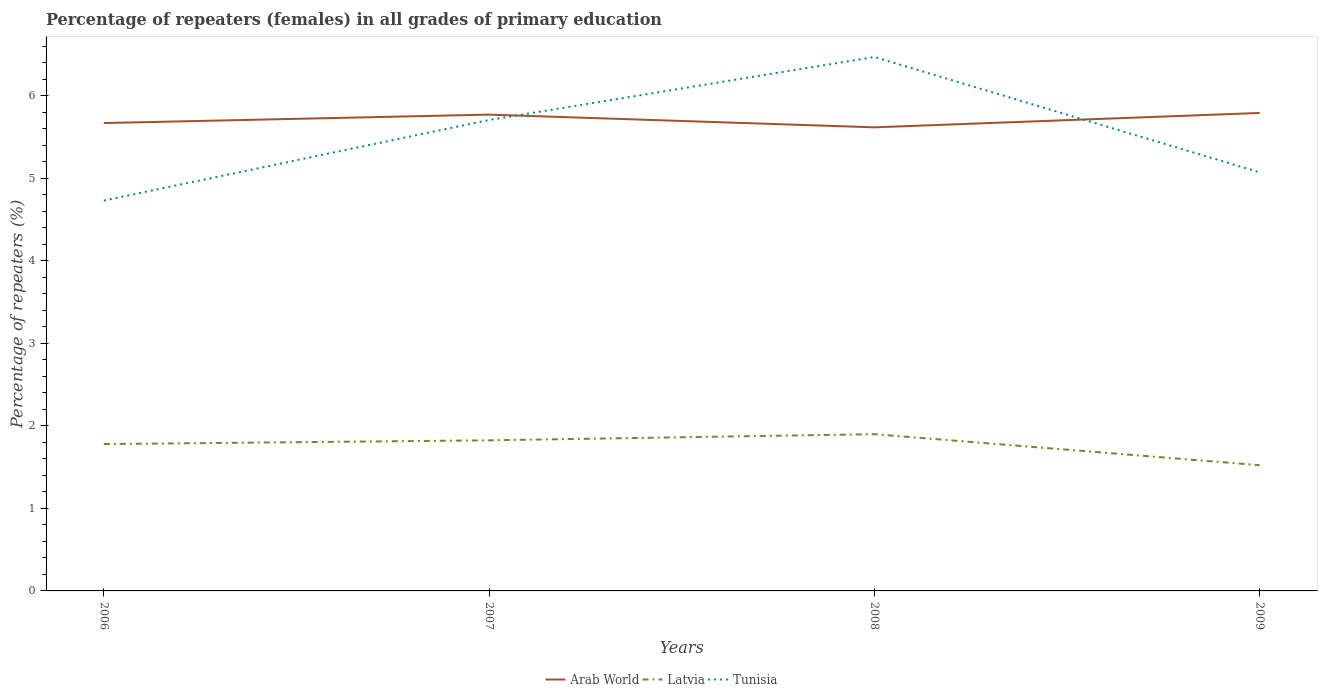How many different coloured lines are there?
Offer a very short reply. 3. Does the line corresponding to Tunisia intersect with the line corresponding to Arab World?
Offer a very short reply. Yes. Is the number of lines equal to the number of legend labels?
Provide a succinct answer. Yes. Across all years, what is the maximum percentage of repeaters (females) in Latvia?
Your answer should be compact. 1.52. What is the total percentage of repeaters (females) in Tunisia in the graph?
Provide a short and direct response. 1.4. What is the difference between the highest and the second highest percentage of repeaters (females) in Arab World?
Your response must be concise. 0.17. What is the difference between the highest and the lowest percentage of repeaters (females) in Tunisia?
Your answer should be compact. 2. Is the percentage of repeaters (females) in Tunisia strictly greater than the percentage of repeaters (females) in Arab World over the years?
Offer a very short reply. No. Does the graph contain any zero values?
Your answer should be very brief. No. Where does the legend appear in the graph?
Ensure brevity in your answer.  Bottom center. How many legend labels are there?
Give a very brief answer. 3. How are the legend labels stacked?
Provide a short and direct response. Horizontal. What is the title of the graph?
Your response must be concise. Percentage of repeaters (females) in all grades of primary education. What is the label or title of the X-axis?
Your answer should be compact. Years. What is the label or title of the Y-axis?
Your answer should be very brief. Percentage of repeaters (%). What is the Percentage of repeaters (%) of Arab World in 2006?
Provide a short and direct response. 5.67. What is the Percentage of repeaters (%) in Latvia in 2006?
Provide a succinct answer. 1.78. What is the Percentage of repeaters (%) of Tunisia in 2006?
Your answer should be very brief. 4.73. What is the Percentage of repeaters (%) in Arab World in 2007?
Your answer should be compact. 5.77. What is the Percentage of repeaters (%) in Latvia in 2007?
Your answer should be compact. 1.83. What is the Percentage of repeaters (%) in Tunisia in 2007?
Provide a short and direct response. 5.71. What is the Percentage of repeaters (%) in Arab World in 2008?
Give a very brief answer. 5.62. What is the Percentage of repeaters (%) of Latvia in 2008?
Keep it short and to the point. 1.9. What is the Percentage of repeaters (%) of Tunisia in 2008?
Your response must be concise. 6.47. What is the Percentage of repeaters (%) in Arab World in 2009?
Offer a terse response. 5.79. What is the Percentage of repeaters (%) in Latvia in 2009?
Your answer should be compact. 1.52. What is the Percentage of repeaters (%) in Tunisia in 2009?
Ensure brevity in your answer.  5.07. Across all years, what is the maximum Percentage of repeaters (%) in Arab World?
Offer a terse response. 5.79. Across all years, what is the maximum Percentage of repeaters (%) in Latvia?
Make the answer very short. 1.9. Across all years, what is the maximum Percentage of repeaters (%) of Tunisia?
Make the answer very short. 6.47. Across all years, what is the minimum Percentage of repeaters (%) in Arab World?
Offer a very short reply. 5.62. Across all years, what is the minimum Percentage of repeaters (%) of Latvia?
Offer a terse response. 1.52. Across all years, what is the minimum Percentage of repeaters (%) of Tunisia?
Your response must be concise. 4.73. What is the total Percentage of repeaters (%) of Arab World in the graph?
Ensure brevity in your answer.  22.86. What is the total Percentage of repeaters (%) of Latvia in the graph?
Your response must be concise. 7.03. What is the total Percentage of repeaters (%) in Tunisia in the graph?
Provide a short and direct response. 21.99. What is the difference between the Percentage of repeaters (%) of Arab World in 2006 and that in 2007?
Provide a short and direct response. -0.1. What is the difference between the Percentage of repeaters (%) in Latvia in 2006 and that in 2007?
Offer a very short reply. -0.05. What is the difference between the Percentage of repeaters (%) of Tunisia in 2006 and that in 2007?
Give a very brief answer. -0.98. What is the difference between the Percentage of repeaters (%) in Arab World in 2006 and that in 2008?
Your answer should be compact. 0.05. What is the difference between the Percentage of repeaters (%) of Latvia in 2006 and that in 2008?
Your answer should be compact. -0.12. What is the difference between the Percentage of repeaters (%) in Tunisia in 2006 and that in 2008?
Your answer should be compact. -1.74. What is the difference between the Percentage of repeaters (%) of Arab World in 2006 and that in 2009?
Provide a short and direct response. -0.12. What is the difference between the Percentage of repeaters (%) of Latvia in 2006 and that in 2009?
Offer a terse response. 0.26. What is the difference between the Percentage of repeaters (%) in Tunisia in 2006 and that in 2009?
Keep it short and to the point. -0.34. What is the difference between the Percentage of repeaters (%) in Arab World in 2007 and that in 2008?
Offer a very short reply. 0.15. What is the difference between the Percentage of repeaters (%) of Latvia in 2007 and that in 2008?
Your response must be concise. -0.07. What is the difference between the Percentage of repeaters (%) in Tunisia in 2007 and that in 2008?
Your answer should be very brief. -0.76. What is the difference between the Percentage of repeaters (%) of Arab World in 2007 and that in 2009?
Give a very brief answer. -0.02. What is the difference between the Percentage of repeaters (%) in Latvia in 2007 and that in 2009?
Your answer should be very brief. 0.3. What is the difference between the Percentage of repeaters (%) in Tunisia in 2007 and that in 2009?
Provide a succinct answer. 0.63. What is the difference between the Percentage of repeaters (%) in Arab World in 2008 and that in 2009?
Offer a very short reply. -0.17. What is the difference between the Percentage of repeaters (%) of Latvia in 2008 and that in 2009?
Your answer should be compact. 0.38. What is the difference between the Percentage of repeaters (%) in Tunisia in 2008 and that in 2009?
Provide a succinct answer. 1.4. What is the difference between the Percentage of repeaters (%) in Arab World in 2006 and the Percentage of repeaters (%) in Latvia in 2007?
Provide a short and direct response. 3.85. What is the difference between the Percentage of repeaters (%) in Arab World in 2006 and the Percentage of repeaters (%) in Tunisia in 2007?
Offer a very short reply. -0.04. What is the difference between the Percentage of repeaters (%) of Latvia in 2006 and the Percentage of repeaters (%) of Tunisia in 2007?
Provide a succinct answer. -3.93. What is the difference between the Percentage of repeaters (%) of Arab World in 2006 and the Percentage of repeaters (%) of Latvia in 2008?
Your answer should be very brief. 3.77. What is the difference between the Percentage of repeaters (%) of Arab World in 2006 and the Percentage of repeaters (%) of Tunisia in 2008?
Make the answer very short. -0.8. What is the difference between the Percentage of repeaters (%) of Latvia in 2006 and the Percentage of repeaters (%) of Tunisia in 2008?
Ensure brevity in your answer.  -4.69. What is the difference between the Percentage of repeaters (%) of Arab World in 2006 and the Percentage of repeaters (%) of Latvia in 2009?
Your answer should be very brief. 4.15. What is the difference between the Percentage of repeaters (%) in Arab World in 2006 and the Percentage of repeaters (%) in Tunisia in 2009?
Your answer should be very brief. 0.6. What is the difference between the Percentage of repeaters (%) in Latvia in 2006 and the Percentage of repeaters (%) in Tunisia in 2009?
Give a very brief answer. -3.29. What is the difference between the Percentage of repeaters (%) of Arab World in 2007 and the Percentage of repeaters (%) of Latvia in 2008?
Your response must be concise. 3.87. What is the difference between the Percentage of repeaters (%) of Arab World in 2007 and the Percentage of repeaters (%) of Tunisia in 2008?
Provide a succinct answer. -0.7. What is the difference between the Percentage of repeaters (%) of Latvia in 2007 and the Percentage of repeaters (%) of Tunisia in 2008?
Give a very brief answer. -4.65. What is the difference between the Percentage of repeaters (%) in Arab World in 2007 and the Percentage of repeaters (%) in Latvia in 2009?
Provide a short and direct response. 4.25. What is the difference between the Percentage of repeaters (%) in Arab World in 2007 and the Percentage of repeaters (%) in Tunisia in 2009?
Offer a terse response. 0.7. What is the difference between the Percentage of repeaters (%) in Latvia in 2007 and the Percentage of repeaters (%) in Tunisia in 2009?
Provide a succinct answer. -3.25. What is the difference between the Percentage of repeaters (%) in Arab World in 2008 and the Percentage of repeaters (%) in Latvia in 2009?
Keep it short and to the point. 4.1. What is the difference between the Percentage of repeaters (%) of Arab World in 2008 and the Percentage of repeaters (%) of Tunisia in 2009?
Offer a very short reply. 0.55. What is the difference between the Percentage of repeaters (%) in Latvia in 2008 and the Percentage of repeaters (%) in Tunisia in 2009?
Your answer should be very brief. -3.17. What is the average Percentage of repeaters (%) in Arab World per year?
Offer a terse response. 5.71. What is the average Percentage of repeaters (%) of Latvia per year?
Provide a succinct answer. 1.76. What is the average Percentage of repeaters (%) of Tunisia per year?
Your answer should be very brief. 5.5. In the year 2006, what is the difference between the Percentage of repeaters (%) in Arab World and Percentage of repeaters (%) in Latvia?
Provide a succinct answer. 3.89. In the year 2006, what is the difference between the Percentage of repeaters (%) of Arab World and Percentage of repeaters (%) of Tunisia?
Ensure brevity in your answer.  0.94. In the year 2006, what is the difference between the Percentage of repeaters (%) in Latvia and Percentage of repeaters (%) in Tunisia?
Provide a succinct answer. -2.95. In the year 2007, what is the difference between the Percentage of repeaters (%) of Arab World and Percentage of repeaters (%) of Latvia?
Your answer should be compact. 3.95. In the year 2007, what is the difference between the Percentage of repeaters (%) in Arab World and Percentage of repeaters (%) in Tunisia?
Give a very brief answer. 0.06. In the year 2007, what is the difference between the Percentage of repeaters (%) of Latvia and Percentage of repeaters (%) of Tunisia?
Give a very brief answer. -3.88. In the year 2008, what is the difference between the Percentage of repeaters (%) of Arab World and Percentage of repeaters (%) of Latvia?
Give a very brief answer. 3.72. In the year 2008, what is the difference between the Percentage of repeaters (%) in Arab World and Percentage of repeaters (%) in Tunisia?
Give a very brief answer. -0.85. In the year 2008, what is the difference between the Percentage of repeaters (%) in Latvia and Percentage of repeaters (%) in Tunisia?
Provide a short and direct response. -4.57. In the year 2009, what is the difference between the Percentage of repeaters (%) in Arab World and Percentage of repeaters (%) in Latvia?
Provide a short and direct response. 4.27. In the year 2009, what is the difference between the Percentage of repeaters (%) of Arab World and Percentage of repeaters (%) of Tunisia?
Offer a very short reply. 0.72. In the year 2009, what is the difference between the Percentage of repeaters (%) of Latvia and Percentage of repeaters (%) of Tunisia?
Offer a terse response. -3.55. What is the ratio of the Percentage of repeaters (%) of Arab World in 2006 to that in 2007?
Your response must be concise. 0.98. What is the ratio of the Percentage of repeaters (%) in Latvia in 2006 to that in 2007?
Offer a terse response. 0.98. What is the ratio of the Percentage of repeaters (%) of Tunisia in 2006 to that in 2007?
Ensure brevity in your answer.  0.83. What is the ratio of the Percentage of repeaters (%) in Arab World in 2006 to that in 2008?
Your response must be concise. 1.01. What is the ratio of the Percentage of repeaters (%) in Latvia in 2006 to that in 2008?
Provide a short and direct response. 0.94. What is the ratio of the Percentage of repeaters (%) in Tunisia in 2006 to that in 2008?
Your answer should be compact. 0.73. What is the ratio of the Percentage of repeaters (%) of Arab World in 2006 to that in 2009?
Provide a succinct answer. 0.98. What is the ratio of the Percentage of repeaters (%) of Latvia in 2006 to that in 2009?
Ensure brevity in your answer.  1.17. What is the ratio of the Percentage of repeaters (%) of Tunisia in 2006 to that in 2009?
Your answer should be very brief. 0.93. What is the ratio of the Percentage of repeaters (%) in Arab World in 2007 to that in 2008?
Keep it short and to the point. 1.03. What is the ratio of the Percentage of repeaters (%) in Latvia in 2007 to that in 2008?
Offer a terse response. 0.96. What is the ratio of the Percentage of repeaters (%) in Tunisia in 2007 to that in 2008?
Give a very brief answer. 0.88. What is the ratio of the Percentage of repeaters (%) in Arab World in 2007 to that in 2009?
Make the answer very short. 1. What is the ratio of the Percentage of repeaters (%) in Latvia in 2007 to that in 2009?
Make the answer very short. 1.2. What is the ratio of the Percentage of repeaters (%) in Tunisia in 2007 to that in 2009?
Provide a short and direct response. 1.13. What is the ratio of the Percentage of repeaters (%) in Arab World in 2008 to that in 2009?
Provide a short and direct response. 0.97. What is the ratio of the Percentage of repeaters (%) of Latvia in 2008 to that in 2009?
Offer a terse response. 1.25. What is the ratio of the Percentage of repeaters (%) of Tunisia in 2008 to that in 2009?
Your response must be concise. 1.28. What is the difference between the highest and the second highest Percentage of repeaters (%) of Arab World?
Make the answer very short. 0.02. What is the difference between the highest and the second highest Percentage of repeaters (%) in Latvia?
Your answer should be compact. 0.07. What is the difference between the highest and the second highest Percentage of repeaters (%) in Tunisia?
Your answer should be compact. 0.76. What is the difference between the highest and the lowest Percentage of repeaters (%) of Arab World?
Keep it short and to the point. 0.17. What is the difference between the highest and the lowest Percentage of repeaters (%) in Latvia?
Keep it short and to the point. 0.38. What is the difference between the highest and the lowest Percentage of repeaters (%) of Tunisia?
Ensure brevity in your answer.  1.74. 